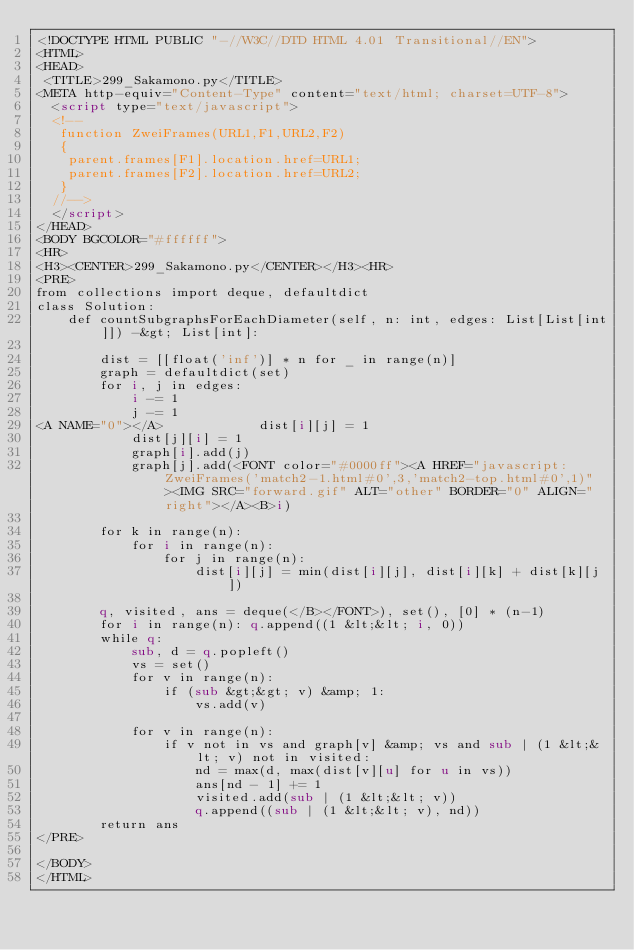Convert code to text. <code><loc_0><loc_0><loc_500><loc_500><_HTML_><!DOCTYPE HTML PUBLIC "-//W3C//DTD HTML 4.01 Transitional//EN">
<HTML>
<HEAD>
 <TITLE>299_Sakamono.py</TITLE>
<META http-equiv="Content-Type" content="text/html; charset=UTF-8">
  <script type="text/javascript">
  <!--
   function ZweiFrames(URL1,F1,URL2,F2)
   {
    parent.frames[F1].location.href=URL1;
    parent.frames[F2].location.href=URL2;
   }
  //-->
  </script>
</HEAD>
<BODY BGCOLOR="#ffffff">
<HR>
<H3><CENTER>299_Sakamono.py</CENTER></H3><HR>
<PRE>
from collections import deque, defaultdict
class Solution:
    def countSubgraphsForEachDiameter(self, n: int, edges: List[List[int]]) -&gt; List[int]:
        
        dist = [[float('inf')] * n for _ in range(n)]
        graph = defaultdict(set)
        for i, j in edges:
            i -= 1
            j -= 1
<A NAME="0"></A>            dist[i][j] = 1
            dist[j][i] = 1
            graph[i].add(j)
            graph[j].add(<FONT color="#0000ff"><A HREF="javascript:ZweiFrames('match2-1.html#0',3,'match2-top.html#0',1)"><IMG SRC="forward.gif" ALT="other" BORDER="0" ALIGN="right"></A><B>i)
        
        for k in range(n):
            for i in range(n):
                for j in range(n):
                    dist[i][j] = min(dist[i][j], dist[i][k] + dist[k][j])
                    
        q, visited, ans = deque(</B></FONT>), set(), [0] * (n-1)
        for i in range(n): q.append((1 &lt;&lt; i, 0))
        while q:
            sub, d = q.popleft()
            vs = set()
            for v in range(n):
                if (sub &gt;&gt; v) &amp; 1:
                    vs.add(v)
                    
            for v in range(n):
                if v not in vs and graph[v] &amp; vs and sub | (1 &lt;&lt; v) not in visited:
                    nd = max(d, max(dist[v][u] for u in vs))
                    ans[nd - 1] += 1
                    visited.add(sub | (1 &lt;&lt; v))
                    q.append((sub | (1 &lt;&lt; v), nd))
        return ans
</PRE>

</BODY>
</HTML>
</code> 